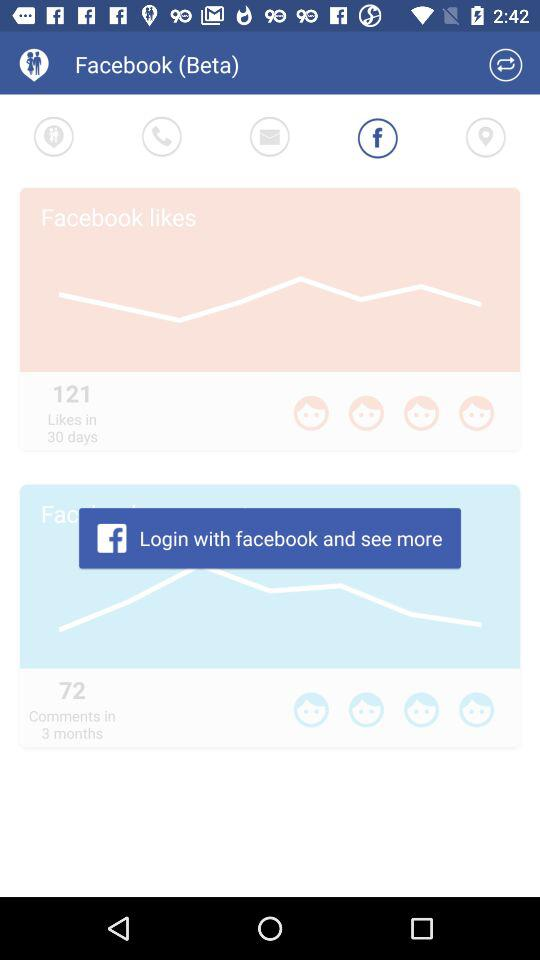What is the application name? The application name is "Facebook (Beta)". 